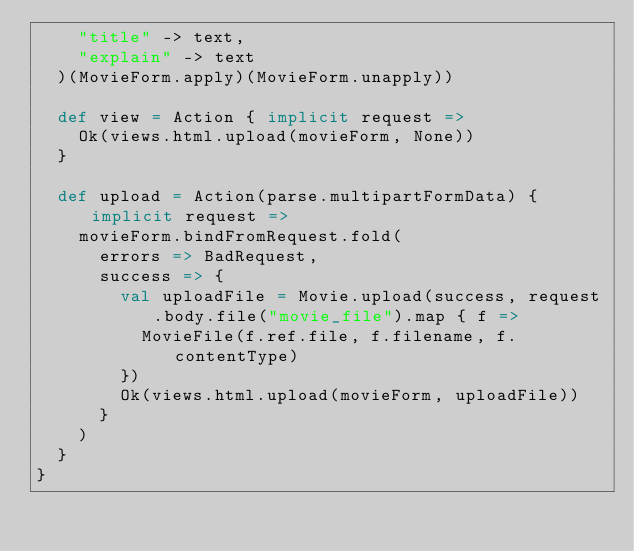Convert code to text. <code><loc_0><loc_0><loc_500><loc_500><_Scala_>    "title" -> text,
    "explain" -> text
  )(MovieForm.apply)(MovieForm.unapply))

  def view = Action { implicit request =>
    Ok(views.html.upload(movieForm, None))
  }

  def upload = Action(parse.multipartFormData) { implicit request =>
    movieForm.bindFromRequest.fold(
      errors => BadRequest,
      success => {
        val uploadFile = Movie.upload(success, request.body.file("movie_file").map { f =>
          MovieFile(f.ref.file, f.filename, f.contentType)
        })
        Ok(views.html.upload(movieForm, uploadFile))
      }
    )
  }
}
</code> 